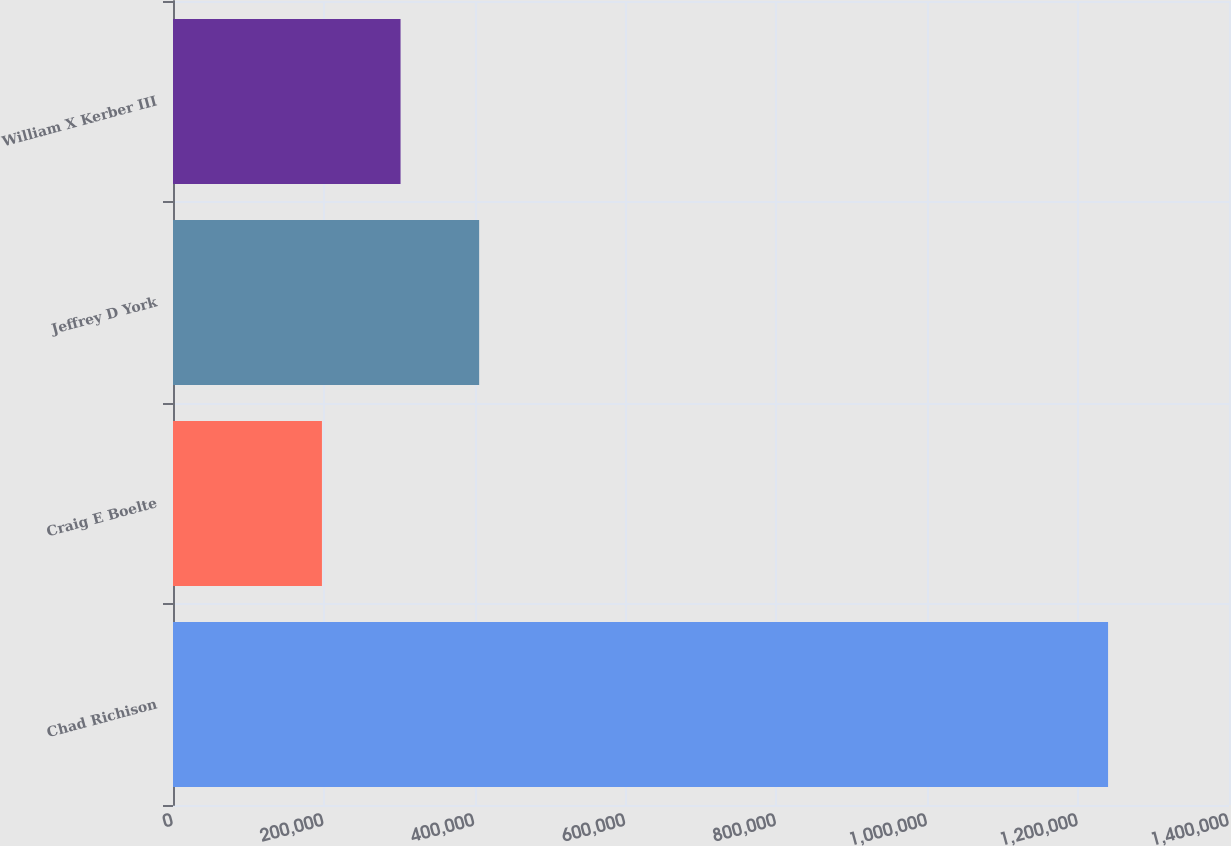Convert chart. <chart><loc_0><loc_0><loc_500><loc_500><bar_chart><fcel>Chad Richison<fcel>Craig E Boelte<fcel>Jeffrey D York<fcel>William X Kerber III<nl><fcel>1.23967e+06<fcel>197451<fcel>405895<fcel>301673<nl></chart> 